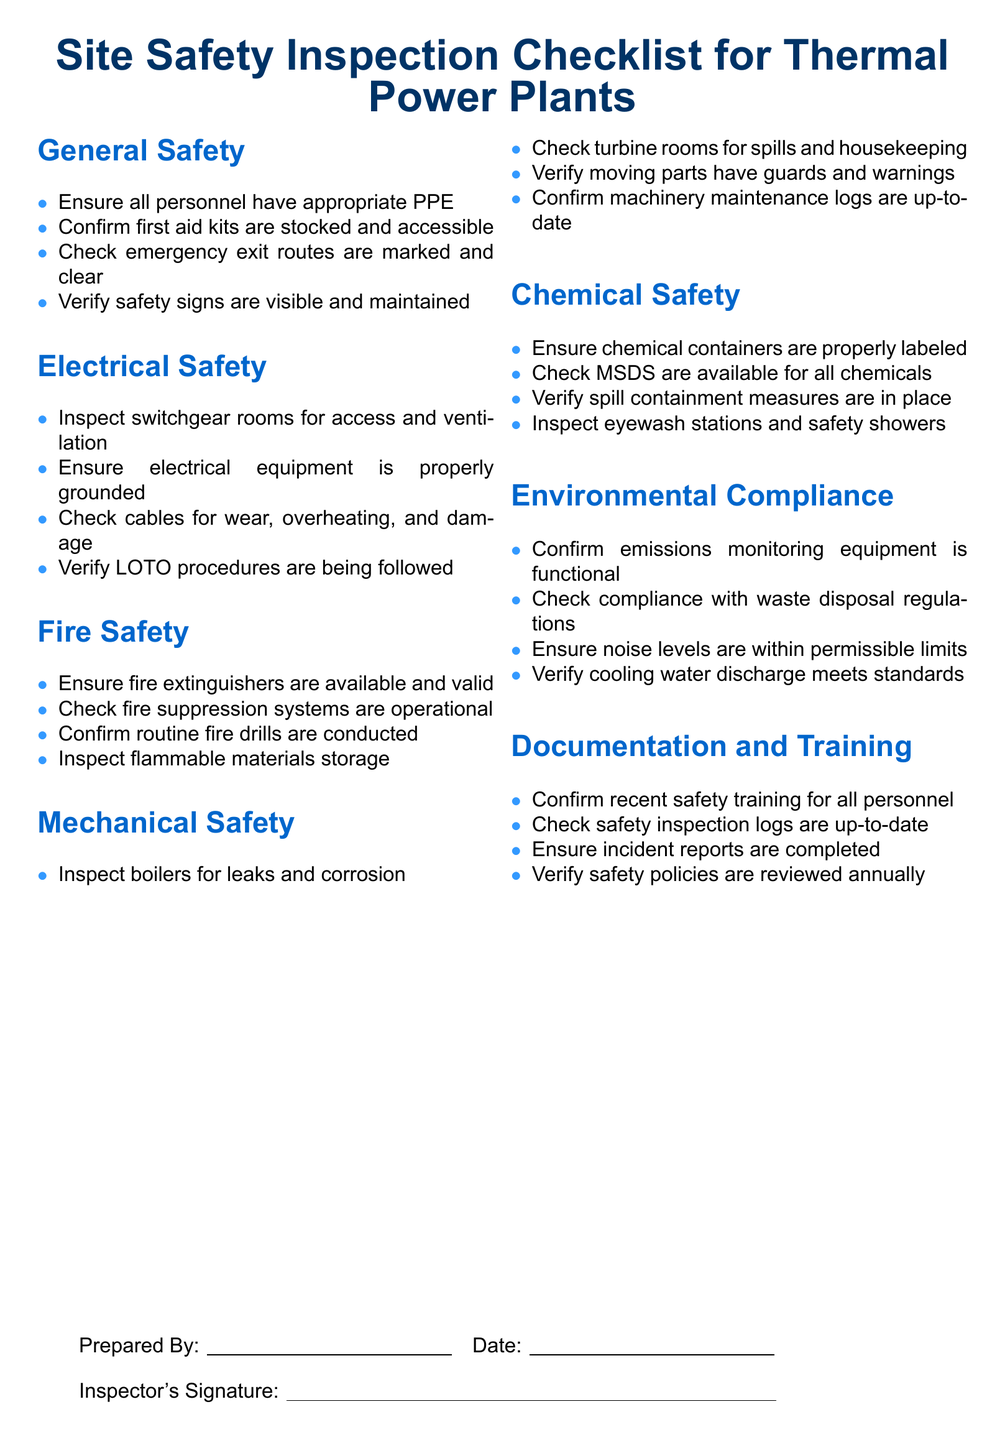what is the main title of the document? The main title is prominently displayed at the top of the document, indicating its purpose.
Answer: Site Safety Inspection Checklist for Thermal Power Plants how many sections are there in the checklist? The document consists of distinct sections, each covering a specific aspect of safety.
Answer: 7 what item confirms the availability of fire extinguishers? This item specifically checks for the availability and validity of essential firefighting equipment.
Answer: Ensure fire extinguishers are available and valid what should be verified regarding electrical equipment? This item addresses the safety standard of grounding for electrical equipment.
Answer: Ensure electrical equipment is properly grounded what type of safety is covered under the section titled "Environmental Compliance"? The section addresses various safety measures related to environmental regulations.
Answer: Emissions monitoring equipment who is responsible for signing the checklist? The document has a designated area for the individual who completed the inspection to acknowledge it.
Answer: Inspector's Signature how often should safety policies be reviewed according to the checklist? This item specifically mentions the frequency of reviewing important safety documents.
Answer: Annually 